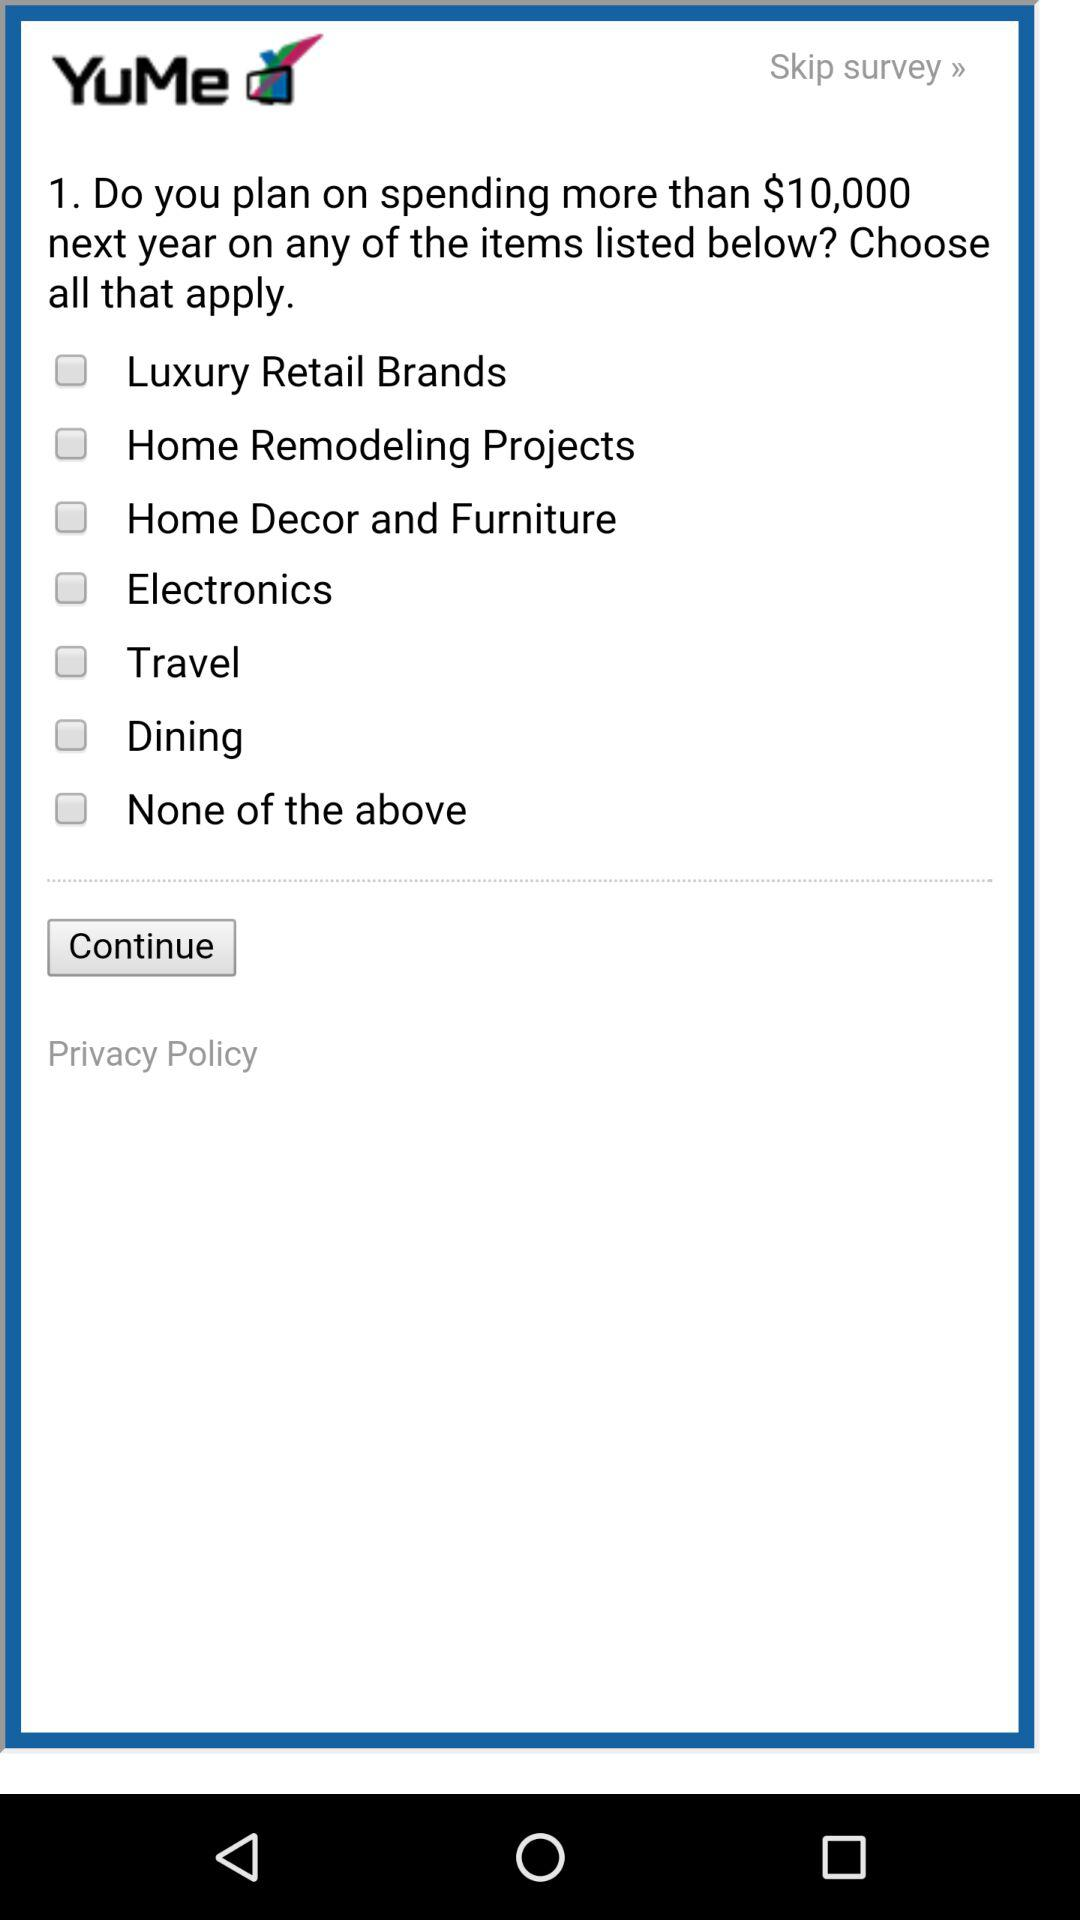What is the amount mentioned in the given question? The amount mentioned in the given question is $10,000. 